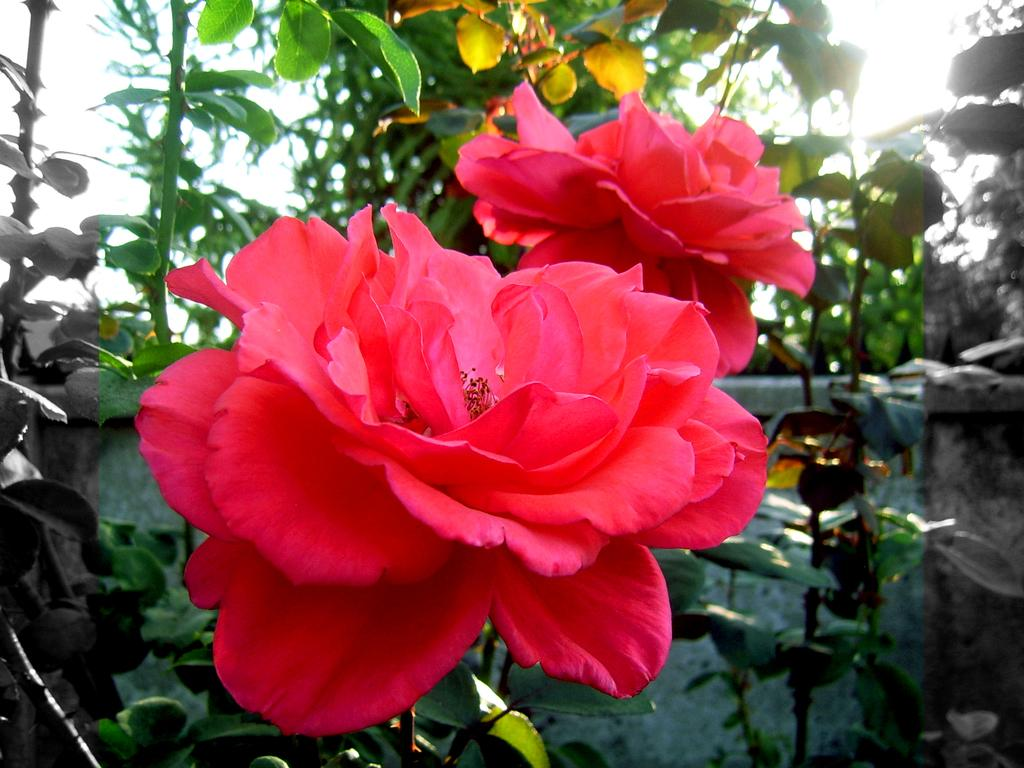What is the main subject of the image? The main subject of the image is rose flowers. What color are the rose flowers? The rose flowers are red in color. What other plants can be seen in the image? There are plants at the bottom of the image. What is visible in the background of the image? There is a wall, trees, and the sky visible in the background of the image. How many pieces of fruit can be seen hanging from the branches of the trees in the background? There is no fruit visible in the image; only trees and the sky are present in the background. 